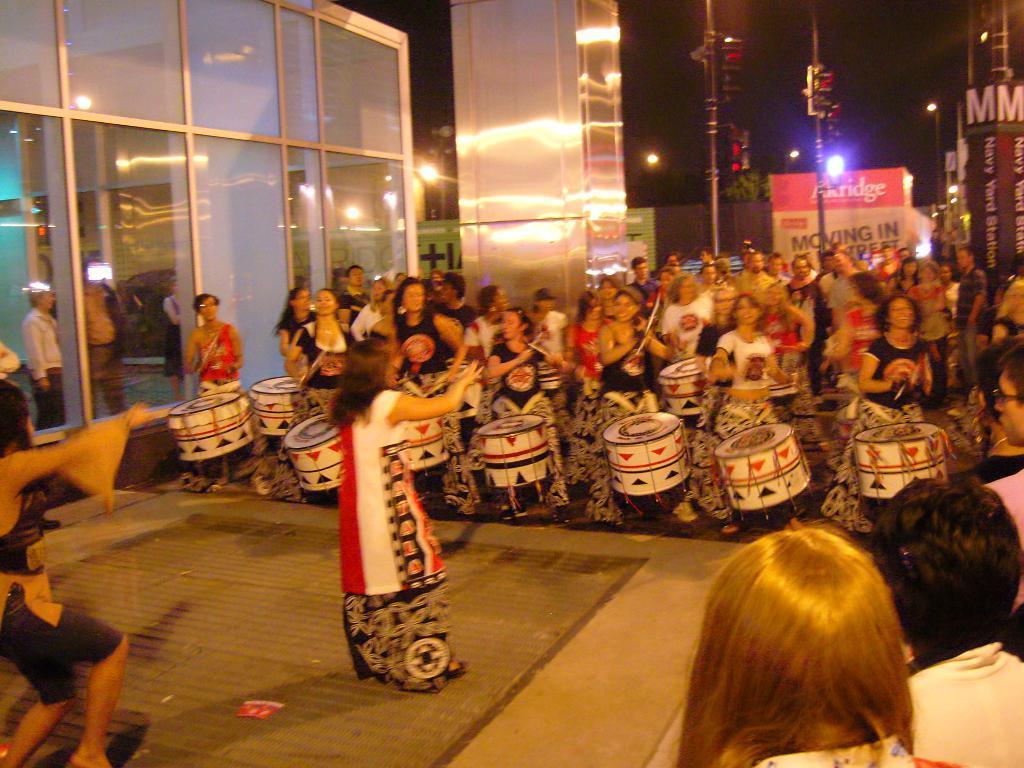In one or two sentences, can you explain what this image depicts? Here we can see group of persons are standing and playing the drums, and in front here is the woman standing, and here are the glass door, and here are the lights. 